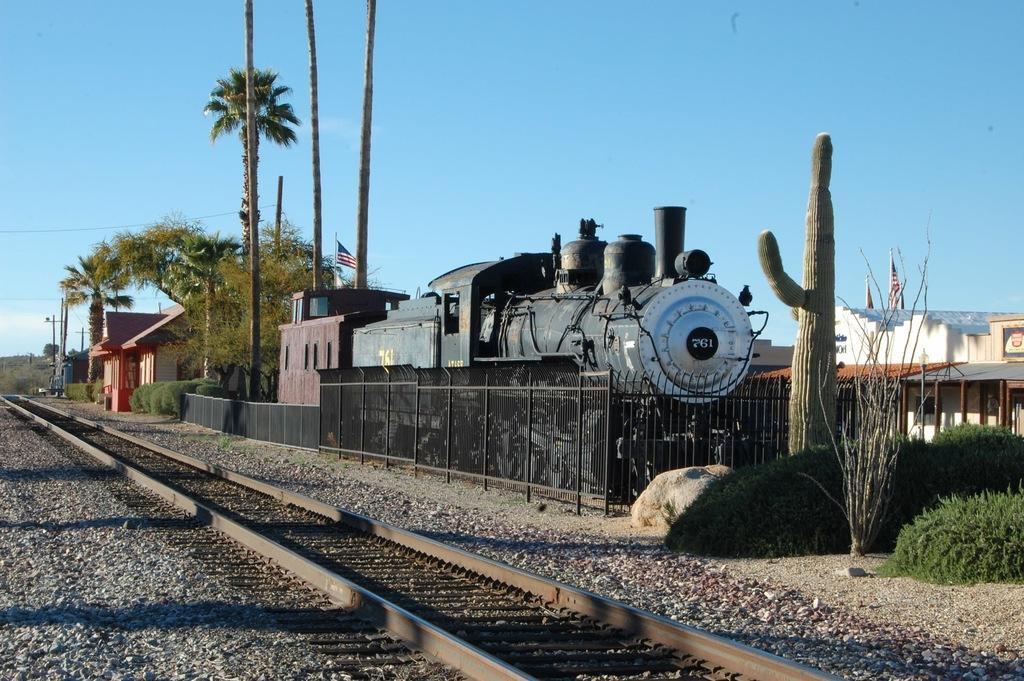Please provide a concise description of this image. In this image I can see the train and I can also see the track, few trees in green color, buildings, few light poles and the sky is in blue color. 